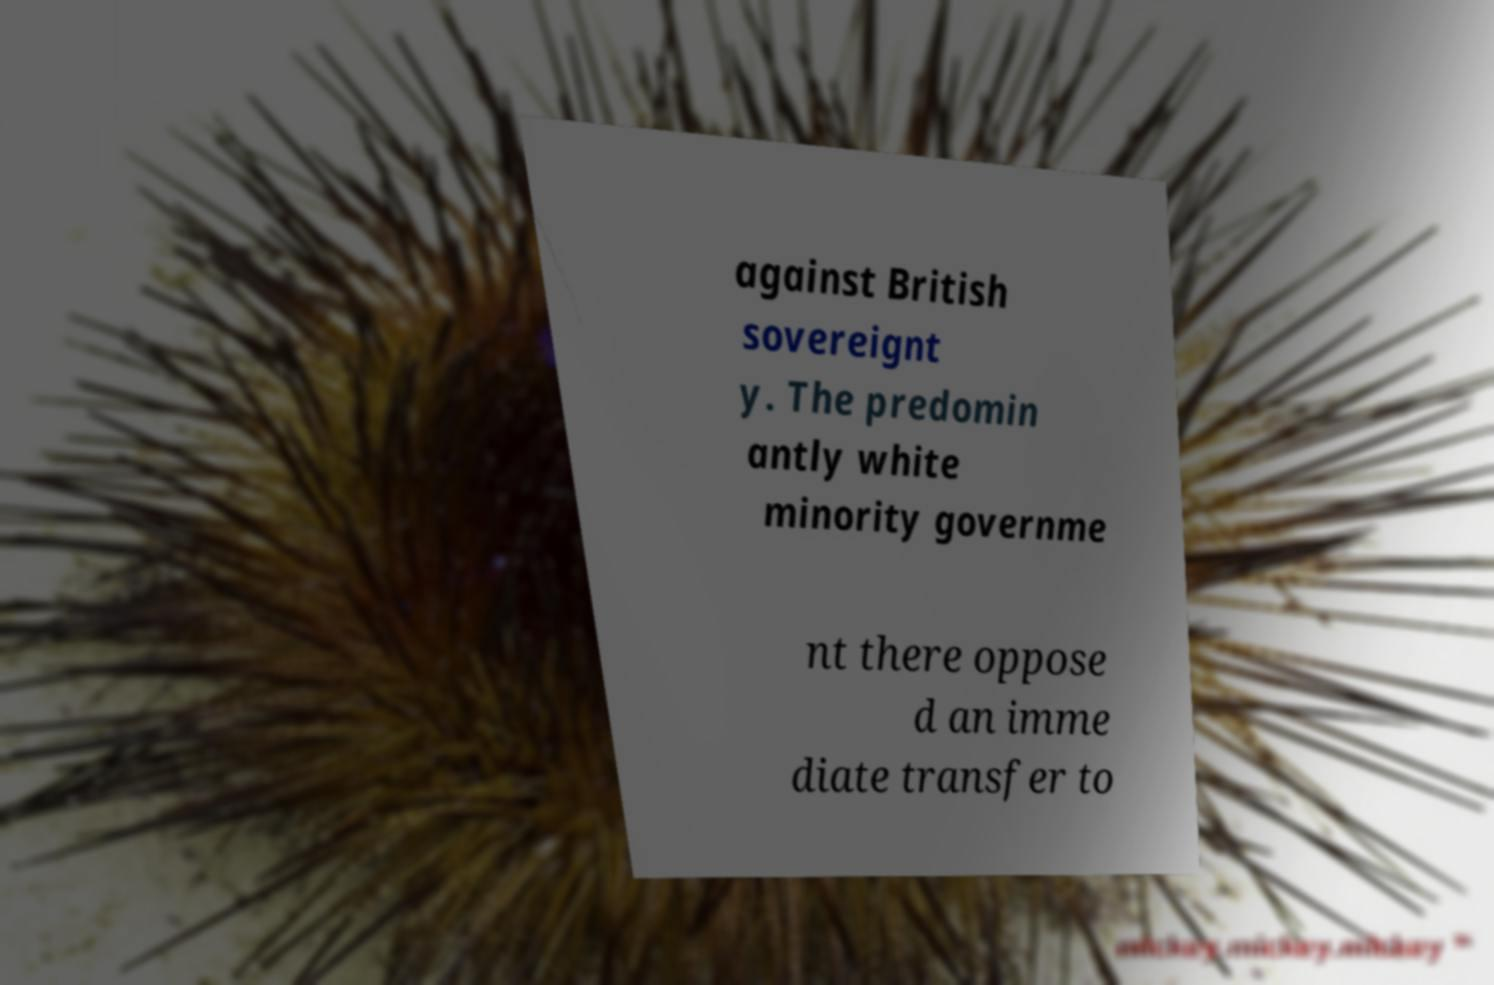For documentation purposes, I need the text within this image transcribed. Could you provide that? against British sovereignt y. The predomin antly white minority governme nt there oppose d an imme diate transfer to 